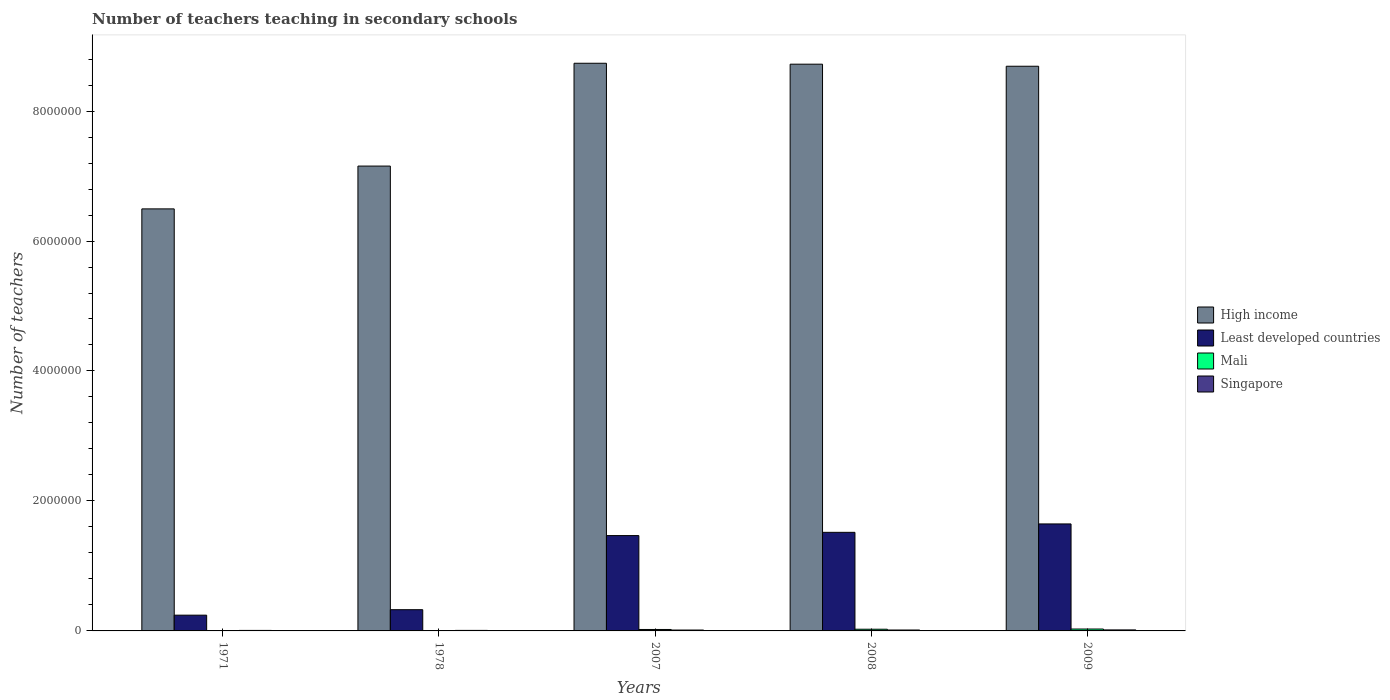How many groups of bars are there?
Provide a short and direct response. 5. How many bars are there on the 2nd tick from the right?
Provide a succinct answer. 4. What is the label of the 1st group of bars from the left?
Offer a terse response. 1971. What is the number of teachers teaching in secondary schools in Mali in 2009?
Ensure brevity in your answer.  2.93e+04. Across all years, what is the maximum number of teachers teaching in secondary schools in High income?
Your answer should be very brief. 8.74e+06. Across all years, what is the minimum number of teachers teaching in secondary schools in Least developed countries?
Your answer should be compact. 2.43e+05. In which year was the number of teachers teaching in secondary schools in Singapore maximum?
Ensure brevity in your answer.  2009. What is the total number of teachers teaching in secondary schools in Least developed countries in the graph?
Offer a very short reply. 5.20e+06. What is the difference between the number of teachers teaching in secondary schools in High income in 1971 and that in 2008?
Provide a short and direct response. -2.23e+06. What is the difference between the number of teachers teaching in secondary schools in Least developed countries in 2007 and the number of teachers teaching in secondary schools in High income in 1978?
Keep it short and to the point. -5.69e+06. What is the average number of teachers teaching in secondary schools in Mali per year?
Ensure brevity in your answer.  1.67e+04. In the year 2009, what is the difference between the number of teachers teaching in secondary schools in Mali and number of teachers teaching in secondary schools in Least developed countries?
Keep it short and to the point. -1.62e+06. What is the ratio of the number of teachers teaching in secondary schools in Mali in 1971 to that in 2007?
Offer a terse response. 0.1. Is the number of teachers teaching in secondary schools in Least developed countries in 1978 less than that in 2009?
Provide a succinct answer. Yes. Is the difference between the number of teachers teaching in secondary schools in Mali in 1971 and 2008 greater than the difference between the number of teachers teaching in secondary schools in Least developed countries in 1971 and 2008?
Your answer should be compact. Yes. What is the difference between the highest and the second highest number of teachers teaching in secondary schools in High income?
Your answer should be compact. 1.41e+04. What is the difference between the highest and the lowest number of teachers teaching in secondary schools in Singapore?
Your answer should be compact. 7654. What does the 2nd bar from the left in 2008 represents?
Your answer should be compact. Least developed countries. What does the 4th bar from the right in 2008 represents?
Offer a terse response. High income. Is it the case that in every year, the sum of the number of teachers teaching in secondary schools in Singapore and number of teachers teaching in secondary schools in Least developed countries is greater than the number of teachers teaching in secondary schools in High income?
Your answer should be compact. No. How many bars are there?
Your response must be concise. 20. How many legend labels are there?
Provide a succinct answer. 4. How are the legend labels stacked?
Ensure brevity in your answer.  Vertical. What is the title of the graph?
Keep it short and to the point. Number of teachers teaching in secondary schools. What is the label or title of the Y-axis?
Provide a short and direct response. Number of teachers. What is the Number of teachers of High income in 1971?
Give a very brief answer. 6.49e+06. What is the Number of teachers in Least developed countries in 1971?
Provide a succinct answer. 2.43e+05. What is the Number of teachers of Mali in 1971?
Give a very brief answer. 2242. What is the Number of teachers in Singapore in 1971?
Make the answer very short. 7906. What is the Number of teachers of High income in 1978?
Give a very brief answer. 7.15e+06. What is the Number of teachers in Least developed countries in 1978?
Keep it short and to the point. 3.27e+05. What is the Number of teachers of Mali in 1978?
Provide a succinct answer. 3555. What is the Number of teachers in Singapore in 1978?
Offer a very short reply. 8050. What is the Number of teachers in High income in 2007?
Provide a succinct answer. 8.74e+06. What is the Number of teachers in Least developed countries in 2007?
Your answer should be compact. 1.47e+06. What is the Number of teachers in Mali in 2007?
Offer a very short reply. 2.23e+04. What is the Number of teachers in Singapore in 2007?
Your answer should be very brief. 1.37e+04. What is the Number of teachers in High income in 2008?
Keep it short and to the point. 8.72e+06. What is the Number of teachers of Least developed countries in 2008?
Keep it short and to the point. 1.52e+06. What is the Number of teachers in Mali in 2008?
Ensure brevity in your answer.  2.60e+04. What is the Number of teachers in Singapore in 2008?
Provide a short and direct response. 1.41e+04. What is the Number of teachers in High income in 2009?
Your answer should be compact. 8.69e+06. What is the Number of teachers of Least developed countries in 2009?
Your response must be concise. 1.65e+06. What is the Number of teachers in Mali in 2009?
Provide a short and direct response. 2.93e+04. What is the Number of teachers of Singapore in 2009?
Make the answer very short. 1.56e+04. Across all years, what is the maximum Number of teachers of High income?
Your answer should be very brief. 8.74e+06. Across all years, what is the maximum Number of teachers in Least developed countries?
Provide a succinct answer. 1.65e+06. Across all years, what is the maximum Number of teachers in Mali?
Offer a terse response. 2.93e+04. Across all years, what is the maximum Number of teachers of Singapore?
Make the answer very short. 1.56e+04. Across all years, what is the minimum Number of teachers of High income?
Make the answer very short. 6.49e+06. Across all years, what is the minimum Number of teachers of Least developed countries?
Ensure brevity in your answer.  2.43e+05. Across all years, what is the minimum Number of teachers of Mali?
Provide a succinct answer. 2242. Across all years, what is the minimum Number of teachers in Singapore?
Your answer should be compact. 7906. What is the total Number of teachers in High income in the graph?
Ensure brevity in your answer.  3.98e+07. What is the total Number of teachers in Least developed countries in the graph?
Offer a very short reply. 5.20e+06. What is the total Number of teachers of Mali in the graph?
Provide a succinct answer. 8.34e+04. What is the total Number of teachers of Singapore in the graph?
Your answer should be very brief. 5.93e+04. What is the difference between the Number of teachers in High income in 1971 and that in 1978?
Your response must be concise. -6.59e+05. What is the difference between the Number of teachers in Least developed countries in 1971 and that in 1978?
Your answer should be very brief. -8.40e+04. What is the difference between the Number of teachers in Mali in 1971 and that in 1978?
Offer a terse response. -1313. What is the difference between the Number of teachers in Singapore in 1971 and that in 1978?
Your answer should be very brief. -144. What is the difference between the Number of teachers of High income in 1971 and that in 2007?
Your answer should be compact. -2.24e+06. What is the difference between the Number of teachers of Least developed countries in 1971 and that in 2007?
Provide a short and direct response. -1.22e+06. What is the difference between the Number of teachers in Mali in 1971 and that in 2007?
Ensure brevity in your answer.  -2.00e+04. What is the difference between the Number of teachers of Singapore in 1971 and that in 2007?
Your answer should be very brief. -5780. What is the difference between the Number of teachers of High income in 1971 and that in 2008?
Make the answer very short. -2.23e+06. What is the difference between the Number of teachers of Least developed countries in 1971 and that in 2008?
Offer a terse response. -1.27e+06. What is the difference between the Number of teachers of Mali in 1971 and that in 2008?
Your response must be concise. -2.37e+04. What is the difference between the Number of teachers of Singapore in 1971 and that in 2008?
Ensure brevity in your answer.  -6222. What is the difference between the Number of teachers of High income in 1971 and that in 2009?
Provide a succinct answer. -2.19e+06. What is the difference between the Number of teachers in Least developed countries in 1971 and that in 2009?
Make the answer very short. -1.40e+06. What is the difference between the Number of teachers in Mali in 1971 and that in 2009?
Offer a terse response. -2.71e+04. What is the difference between the Number of teachers in Singapore in 1971 and that in 2009?
Your answer should be very brief. -7654. What is the difference between the Number of teachers of High income in 1978 and that in 2007?
Give a very brief answer. -1.58e+06. What is the difference between the Number of teachers in Least developed countries in 1978 and that in 2007?
Provide a succinct answer. -1.14e+06. What is the difference between the Number of teachers in Mali in 1978 and that in 2007?
Your answer should be compact. -1.87e+04. What is the difference between the Number of teachers in Singapore in 1978 and that in 2007?
Keep it short and to the point. -5636. What is the difference between the Number of teachers of High income in 1978 and that in 2008?
Ensure brevity in your answer.  -1.57e+06. What is the difference between the Number of teachers in Least developed countries in 1978 and that in 2008?
Provide a short and direct response. -1.19e+06. What is the difference between the Number of teachers in Mali in 1978 and that in 2008?
Your response must be concise. -2.24e+04. What is the difference between the Number of teachers of Singapore in 1978 and that in 2008?
Offer a terse response. -6078. What is the difference between the Number of teachers in High income in 1978 and that in 2009?
Keep it short and to the point. -1.54e+06. What is the difference between the Number of teachers of Least developed countries in 1978 and that in 2009?
Provide a short and direct response. -1.32e+06. What is the difference between the Number of teachers in Mali in 1978 and that in 2009?
Ensure brevity in your answer.  -2.58e+04. What is the difference between the Number of teachers of Singapore in 1978 and that in 2009?
Give a very brief answer. -7510. What is the difference between the Number of teachers of High income in 2007 and that in 2008?
Provide a succinct answer. 1.41e+04. What is the difference between the Number of teachers in Least developed countries in 2007 and that in 2008?
Offer a terse response. -4.98e+04. What is the difference between the Number of teachers of Mali in 2007 and that in 2008?
Keep it short and to the point. -3727. What is the difference between the Number of teachers of Singapore in 2007 and that in 2008?
Provide a succinct answer. -442. What is the difference between the Number of teachers of High income in 2007 and that in 2009?
Your answer should be compact. 4.60e+04. What is the difference between the Number of teachers of Least developed countries in 2007 and that in 2009?
Your response must be concise. -1.79e+05. What is the difference between the Number of teachers in Mali in 2007 and that in 2009?
Offer a terse response. -7045. What is the difference between the Number of teachers in Singapore in 2007 and that in 2009?
Make the answer very short. -1874. What is the difference between the Number of teachers in High income in 2008 and that in 2009?
Give a very brief answer. 3.19e+04. What is the difference between the Number of teachers of Least developed countries in 2008 and that in 2009?
Offer a very short reply. -1.30e+05. What is the difference between the Number of teachers in Mali in 2008 and that in 2009?
Your answer should be compact. -3318. What is the difference between the Number of teachers of Singapore in 2008 and that in 2009?
Your answer should be very brief. -1432. What is the difference between the Number of teachers of High income in 1971 and the Number of teachers of Least developed countries in 1978?
Make the answer very short. 6.17e+06. What is the difference between the Number of teachers in High income in 1971 and the Number of teachers in Mali in 1978?
Provide a succinct answer. 6.49e+06. What is the difference between the Number of teachers in High income in 1971 and the Number of teachers in Singapore in 1978?
Provide a succinct answer. 6.49e+06. What is the difference between the Number of teachers of Least developed countries in 1971 and the Number of teachers of Mali in 1978?
Offer a terse response. 2.39e+05. What is the difference between the Number of teachers of Least developed countries in 1971 and the Number of teachers of Singapore in 1978?
Provide a succinct answer. 2.35e+05. What is the difference between the Number of teachers of Mali in 1971 and the Number of teachers of Singapore in 1978?
Offer a very short reply. -5808. What is the difference between the Number of teachers in High income in 1971 and the Number of teachers in Least developed countries in 2007?
Your answer should be compact. 5.03e+06. What is the difference between the Number of teachers in High income in 1971 and the Number of teachers in Mali in 2007?
Provide a succinct answer. 6.47e+06. What is the difference between the Number of teachers in High income in 1971 and the Number of teachers in Singapore in 2007?
Keep it short and to the point. 6.48e+06. What is the difference between the Number of teachers in Least developed countries in 1971 and the Number of teachers in Mali in 2007?
Offer a very short reply. 2.20e+05. What is the difference between the Number of teachers in Least developed countries in 1971 and the Number of teachers in Singapore in 2007?
Your response must be concise. 2.29e+05. What is the difference between the Number of teachers of Mali in 1971 and the Number of teachers of Singapore in 2007?
Provide a succinct answer. -1.14e+04. What is the difference between the Number of teachers in High income in 1971 and the Number of teachers in Least developed countries in 2008?
Ensure brevity in your answer.  4.98e+06. What is the difference between the Number of teachers in High income in 1971 and the Number of teachers in Mali in 2008?
Offer a very short reply. 6.47e+06. What is the difference between the Number of teachers in High income in 1971 and the Number of teachers in Singapore in 2008?
Keep it short and to the point. 6.48e+06. What is the difference between the Number of teachers of Least developed countries in 1971 and the Number of teachers of Mali in 2008?
Offer a very short reply. 2.17e+05. What is the difference between the Number of teachers in Least developed countries in 1971 and the Number of teachers in Singapore in 2008?
Offer a very short reply. 2.28e+05. What is the difference between the Number of teachers of Mali in 1971 and the Number of teachers of Singapore in 2008?
Provide a succinct answer. -1.19e+04. What is the difference between the Number of teachers of High income in 1971 and the Number of teachers of Least developed countries in 2009?
Provide a succinct answer. 4.85e+06. What is the difference between the Number of teachers of High income in 1971 and the Number of teachers of Mali in 2009?
Make the answer very short. 6.47e+06. What is the difference between the Number of teachers of High income in 1971 and the Number of teachers of Singapore in 2009?
Make the answer very short. 6.48e+06. What is the difference between the Number of teachers of Least developed countries in 1971 and the Number of teachers of Mali in 2009?
Keep it short and to the point. 2.13e+05. What is the difference between the Number of teachers of Least developed countries in 1971 and the Number of teachers of Singapore in 2009?
Your response must be concise. 2.27e+05. What is the difference between the Number of teachers in Mali in 1971 and the Number of teachers in Singapore in 2009?
Provide a short and direct response. -1.33e+04. What is the difference between the Number of teachers in High income in 1978 and the Number of teachers in Least developed countries in 2007?
Give a very brief answer. 5.69e+06. What is the difference between the Number of teachers of High income in 1978 and the Number of teachers of Mali in 2007?
Your answer should be compact. 7.13e+06. What is the difference between the Number of teachers of High income in 1978 and the Number of teachers of Singapore in 2007?
Your answer should be very brief. 7.14e+06. What is the difference between the Number of teachers of Least developed countries in 1978 and the Number of teachers of Mali in 2007?
Keep it short and to the point. 3.04e+05. What is the difference between the Number of teachers of Least developed countries in 1978 and the Number of teachers of Singapore in 2007?
Your answer should be very brief. 3.13e+05. What is the difference between the Number of teachers in Mali in 1978 and the Number of teachers in Singapore in 2007?
Make the answer very short. -1.01e+04. What is the difference between the Number of teachers in High income in 1978 and the Number of teachers in Least developed countries in 2008?
Ensure brevity in your answer.  5.64e+06. What is the difference between the Number of teachers in High income in 1978 and the Number of teachers in Mali in 2008?
Offer a very short reply. 7.13e+06. What is the difference between the Number of teachers of High income in 1978 and the Number of teachers of Singapore in 2008?
Provide a succinct answer. 7.14e+06. What is the difference between the Number of teachers in Least developed countries in 1978 and the Number of teachers in Mali in 2008?
Make the answer very short. 3.01e+05. What is the difference between the Number of teachers of Least developed countries in 1978 and the Number of teachers of Singapore in 2008?
Give a very brief answer. 3.12e+05. What is the difference between the Number of teachers in Mali in 1978 and the Number of teachers in Singapore in 2008?
Give a very brief answer. -1.06e+04. What is the difference between the Number of teachers of High income in 1978 and the Number of teachers of Least developed countries in 2009?
Provide a short and direct response. 5.51e+06. What is the difference between the Number of teachers in High income in 1978 and the Number of teachers in Mali in 2009?
Ensure brevity in your answer.  7.12e+06. What is the difference between the Number of teachers of High income in 1978 and the Number of teachers of Singapore in 2009?
Offer a very short reply. 7.14e+06. What is the difference between the Number of teachers in Least developed countries in 1978 and the Number of teachers in Mali in 2009?
Make the answer very short. 2.97e+05. What is the difference between the Number of teachers in Least developed countries in 1978 and the Number of teachers in Singapore in 2009?
Your answer should be very brief. 3.11e+05. What is the difference between the Number of teachers in Mali in 1978 and the Number of teachers in Singapore in 2009?
Offer a very short reply. -1.20e+04. What is the difference between the Number of teachers in High income in 2007 and the Number of teachers in Least developed countries in 2008?
Provide a succinct answer. 7.22e+06. What is the difference between the Number of teachers of High income in 2007 and the Number of teachers of Mali in 2008?
Your response must be concise. 8.71e+06. What is the difference between the Number of teachers of High income in 2007 and the Number of teachers of Singapore in 2008?
Your answer should be compact. 8.72e+06. What is the difference between the Number of teachers of Least developed countries in 2007 and the Number of teachers of Mali in 2008?
Your answer should be very brief. 1.44e+06. What is the difference between the Number of teachers of Least developed countries in 2007 and the Number of teachers of Singapore in 2008?
Make the answer very short. 1.45e+06. What is the difference between the Number of teachers in Mali in 2007 and the Number of teachers in Singapore in 2008?
Your response must be concise. 8135. What is the difference between the Number of teachers of High income in 2007 and the Number of teachers of Least developed countries in 2009?
Your answer should be very brief. 7.09e+06. What is the difference between the Number of teachers of High income in 2007 and the Number of teachers of Mali in 2009?
Your answer should be compact. 8.71e+06. What is the difference between the Number of teachers of High income in 2007 and the Number of teachers of Singapore in 2009?
Offer a very short reply. 8.72e+06. What is the difference between the Number of teachers in Least developed countries in 2007 and the Number of teachers in Mali in 2009?
Ensure brevity in your answer.  1.44e+06. What is the difference between the Number of teachers in Least developed countries in 2007 and the Number of teachers in Singapore in 2009?
Keep it short and to the point. 1.45e+06. What is the difference between the Number of teachers in Mali in 2007 and the Number of teachers in Singapore in 2009?
Your answer should be compact. 6703. What is the difference between the Number of teachers of High income in 2008 and the Number of teachers of Least developed countries in 2009?
Make the answer very short. 7.07e+06. What is the difference between the Number of teachers of High income in 2008 and the Number of teachers of Mali in 2009?
Your response must be concise. 8.69e+06. What is the difference between the Number of teachers in High income in 2008 and the Number of teachers in Singapore in 2009?
Make the answer very short. 8.71e+06. What is the difference between the Number of teachers of Least developed countries in 2008 and the Number of teachers of Mali in 2009?
Your response must be concise. 1.49e+06. What is the difference between the Number of teachers in Least developed countries in 2008 and the Number of teachers in Singapore in 2009?
Keep it short and to the point. 1.50e+06. What is the difference between the Number of teachers in Mali in 2008 and the Number of teachers in Singapore in 2009?
Your answer should be very brief. 1.04e+04. What is the average Number of teachers of High income per year?
Your answer should be very brief. 7.96e+06. What is the average Number of teachers of Least developed countries per year?
Provide a short and direct response. 1.04e+06. What is the average Number of teachers of Mali per year?
Ensure brevity in your answer.  1.67e+04. What is the average Number of teachers in Singapore per year?
Give a very brief answer. 1.19e+04. In the year 1971, what is the difference between the Number of teachers in High income and Number of teachers in Least developed countries?
Offer a terse response. 6.25e+06. In the year 1971, what is the difference between the Number of teachers of High income and Number of teachers of Mali?
Give a very brief answer. 6.49e+06. In the year 1971, what is the difference between the Number of teachers in High income and Number of teachers in Singapore?
Offer a very short reply. 6.49e+06. In the year 1971, what is the difference between the Number of teachers of Least developed countries and Number of teachers of Mali?
Offer a terse response. 2.40e+05. In the year 1971, what is the difference between the Number of teachers of Least developed countries and Number of teachers of Singapore?
Your answer should be very brief. 2.35e+05. In the year 1971, what is the difference between the Number of teachers in Mali and Number of teachers in Singapore?
Offer a terse response. -5664. In the year 1978, what is the difference between the Number of teachers in High income and Number of teachers in Least developed countries?
Your answer should be compact. 6.83e+06. In the year 1978, what is the difference between the Number of teachers of High income and Number of teachers of Mali?
Your response must be concise. 7.15e+06. In the year 1978, what is the difference between the Number of teachers of High income and Number of teachers of Singapore?
Give a very brief answer. 7.15e+06. In the year 1978, what is the difference between the Number of teachers of Least developed countries and Number of teachers of Mali?
Make the answer very short. 3.23e+05. In the year 1978, what is the difference between the Number of teachers of Least developed countries and Number of teachers of Singapore?
Provide a short and direct response. 3.18e+05. In the year 1978, what is the difference between the Number of teachers of Mali and Number of teachers of Singapore?
Ensure brevity in your answer.  -4495. In the year 2007, what is the difference between the Number of teachers in High income and Number of teachers in Least developed countries?
Provide a short and direct response. 7.27e+06. In the year 2007, what is the difference between the Number of teachers of High income and Number of teachers of Mali?
Offer a terse response. 8.71e+06. In the year 2007, what is the difference between the Number of teachers of High income and Number of teachers of Singapore?
Give a very brief answer. 8.72e+06. In the year 2007, what is the difference between the Number of teachers in Least developed countries and Number of teachers in Mali?
Give a very brief answer. 1.44e+06. In the year 2007, what is the difference between the Number of teachers of Least developed countries and Number of teachers of Singapore?
Give a very brief answer. 1.45e+06. In the year 2007, what is the difference between the Number of teachers of Mali and Number of teachers of Singapore?
Provide a short and direct response. 8577. In the year 2008, what is the difference between the Number of teachers in High income and Number of teachers in Least developed countries?
Provide a short and direct response. 7.20e+06. In the year 2008, what is the difference between the Number of teachers of High income and Number of teachers of Mali?
Your response must be concise. 8.70e+06. In the year 2008, what is the difference between the Number of teachers of High income and Number of teachers of Singapore?
Provide a succinct answer. 8.71e+06. In the year 2008, what is the difference between the Number of teachers of Least developed countries and Number of teachers of Mali?
Make the answer very short. 1.49e+06. In the year 2008, what is the difference between the Number of teachers of Least developed countries and Number of teachers of Singapore?
Provide a succinct answer. 1.50e+06. In the year 2008, what is the difference between the Number of teachers in Mali and Number of teachers in Singapore?
Offer a terse response. 1.19e+04. In the year 2009, what is the difference between the Number of teachers in High income and Number of teachers in Least developed countries?
Offer a terse response. 7.04e+06. In the year 2009, what is the difference between the Number of teachers in High income and Number of teachers in Mali?
Offer a terse response. 8.66e+06. In the year 2009, what is the difference between the Number of teachers in High income and Number of teachers in Singapore?
Provide a short and direct response. 8.67e+06. In the year 2009, what is the difference between the Number of teachers in Least developed countries and Number of teachers in Mali?
Provide a short and direct response. 1.62e+06. In the year 2009, what is the difference between the Number of teachers of Least developed countries and Number of teachers of Singapore?
Give a very brief answer. 1.63e+06. In the year 2009, what is the difference between the Number of teachers in Mali and Number of teachers in Singapore?
Your answer should be very brief. 1.37e+04. What is the ratio of the Number of teachers in High income in 1971 to that in 1978?
Ensure brevity in your answer.  0.91. What is the ratio of the Number of teachers in Least developed countries in 1971 to that in 1978?
Keep it short and to the point. 0.74. What is the ratio of the Number of teachers of Mali in 1971 to that in 1978?
Offer a terse response. 0.63. What is the ratio of the Number of teachers in Singapore in 1971 to that in 1978?
Provide a short and direct response. 0.98. What is the ratio of the Number of teachers in High income in 1971 to that in 2007?
Your response must be concise. 0.74. What is the ratio of the Number of teachers in Least developed countries in 1971 to that in 2007?
Offer a terse response. 0.17. What is the ratio of the Number of teachers in Mali in 1971 to that in 2007?
Your response must be concise. 0.1. What is the ratio of the Number of teachers in Singapore in 1971 to that in 2007?
Provide a short and direct response. 0.58. What is the ratio of the Number of teachers of High income in 1971 to that in 2008?
Offer a very short reply. 0.74. What is the ratio of the Number of teachers in Least developed countries in 1971 to that in 2008?
Provide a succinct answer. 0.16. What is the ratio of the Number of teachers of Mali in 1971 to that in 2008?
Make the answer very short. 0.09. What is the ratio of the Number of teachers in Singapore in 1971 to that in 2008?
Offer a terse response. 0.56. What is the ratio of the Number of teachers of High income in 1971 to that in 2009?
Provide a short and direct response. 0.75. What is the ratio of the Number of teachers of Least developed countries in 1971 to that in 2009?
Make the answer very short. 0.15. What is the ratio of the Number of teachers of Mali in 1971 to that in 2009?
Offer a terse response. 0.08. What is the ratio of the Number of teachers in Singapore in 1971 to that in 2009?
Give a very brief answer. 0.51. What is the ratio of the Number of teachers in High income in 1978 to that in 2007?
Provide a succinct answer. 0.82. What is the ratio of the Number of teachers of Least developed countries in 1978 to that in 2007?
Your response must be concise. 0.22. What is the ratio of the Number of teachers of Mali in 1978 to that in 2007?
Make the answer very short. 0.16. What is the ratio of the Number of teachers of Singapore in 1978 to that in 2007?
Offer a terse response. 0.59. What is the ratio of the Number of teachers in High income in 1978 to that in 2008?
Ensure brevity in your answer.  0.82. What is the ratio of the Number of teachers of Least developed countries in 1978 to that in 2008?
Offer a very short reply. 0.22. What is the ratio of the Number of teachers of Mali in 1978 to that in 2008?
Your answer should be compact. 0.14. What is the ratio of the Number of teachers of Singapore in 1978 to that in 2008?
Offer a very short reply. 0.57. What is the ratio of the Number of teachers in High income in 1978 to that in 2009?
Provide a short and direct response. 0.82. What is the ratio of the Number of teachers of Least developed countries in 1978 to that in 2009?
Keep it short and to the point. 0.2. What is the ratio of the Number of teachers of Mali in 1978 to that in 2009?
Offer a terse response. 0.12. What is the ratio of the Number of teachers in Singapore in 1978 to that in 2009?
Your response must be concise. 0.52. What is the ratio of the Number of teachers of High income in 2007 to that in 2008?
Your answer should be compact. 1. What is the ratio of the Number of teachers of Least developed countries in 2007 to that in 2008?
Offer a terse response. 0.97. What is the ratio of the Number of teachers in Mali in 2007 to that in 2008?
Make the answer very short. 0.86. What is the ratio of the Number of teachers of Singapore in 2007 to that in 2008?
Your answer should be compact. 0.97. What is the ratio of the Number of teachers in Least developed countries in 2007 to that in 2009?
Offer a very short reply. 0.89. What is the ratio of the Number of teachers of Mali in 2007 to that in 2009?
Your response must be concise. 0.76. What is the ratio of the Number of teachers of Singapore in 2007 to that in 2009?
Make the answer very short. 0.88. What is the ratio of the Number of teachers in High income in 2008 to that in 2009?
Make the answer very short. 1. What is the ratio of the Number of teachers in Least developed countries in 2008 to that in 2009?
Provide a short and direct response. 0.92. What is the ratio of the Number of teachers of Mali in 2008 to that in 2009?
Offer a very short reply. 0.89. What is the ratio of the Number of teachers of Singapore in 2008 to that in 2009?
Provide a succinct answer. 0.91. What is the difference between the highest and the second highest Number of teachers in High income?
Ensure brevity in your answer.  1.41e+04. What is the difference between the highest and the second highest Number of teachers of Least developed countries?
Make the answer very short. 1.30e+05. What is the difference between the highest and the second highest Number of teachers of Mali?
Offer a terse response. 3318. What is the difference between the highest and the second highest Number of teachers in Singapore?
Ensure brevity in your answer.  1432. What is the difference between the highest and the lowest Number of teachers in High income?
Provide a succinct answer. 2.24e+06. What is the difference between the highest and the lowest Number of teachers in Least developed countries?
Give a very brief answer. 1.40e+06. What is the difference between the highest and the lowest Number of teachers in Mali?
Offer a very short reply. 2.71e+04. What is the difference between the highest and the lowest Number of teachers in Singapore?
Provide a succinct answer. 7654. 